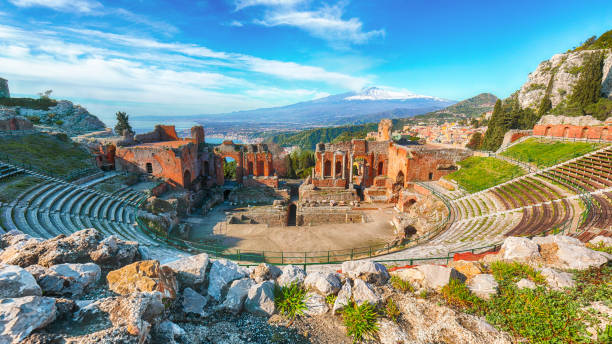What events might have taken place in this ancient theater? In this ancient Greek theater, a myriad of significant events might have unfolded. The theater likely hosted a variety of performances including drama and comedy plays, which were central to Greek culture. These performances would have featured works by famous playwrights such as Aeschylus, Sophocles, Euripides, and Aristophanes. Besides theatrical performances, the theater may also have been a venue for musical contests, poetry readings, and philosophical debates. Public meetings and announcements from civic leaders possibly took place here as well, using the natural acoustics to address large audiences. Theatrical festivals celebrating gods, particularly Dionysus, the god of wine and theater, would have been among the prominent annual events. Imagine the theater during a performance. What might the atmosphere have been like? Picture the theater alive with the energy of an ancient Greek performance. The semi-circular rows would be filled with spectators, eagerly anticipating the show. The hum of the crowd would gradually subside as the play begins, replaced by the rhythmic rise and fall of the actors' voices. The open-air setting allowed natural light to illuminate the stage, creating an interplay of shadows that heightened the dramatic effect. The sound of the Mediterranean breeze, mingling with the distant murmurs of the sea, would add an ambient background to the proceedings. The theater's impressive acoustics carried the actors' voices clearly, even to the farthest seats. As the play progresses, the audience, deeply immersed in the storyline, might respond with audible gasps, laughs, or applause. The scent of wildflowers and the cool touch of the evening air, as the sun set behind Mount Etna, would create an atmosphere of communal enjoyment and cultural reverence. What if a modern concert were held in this ancient theater? Envision a modern concert in this historical gem. The integration of contemporary elements with the ancient architecture would be mesmerizing. Imagine a stage setup carefully preserving the integrity of the historical structure, blending modern LED lights with the ancient stones. The seats, once filled with togas-clad Greeks, now accommodate a diverse audience in modern attire. The acoustics, designed centuries ago to amplify unamplified voices, would now carry the melodies of electric guitars and digital instruments. As the sun sets, the lights illuminate the night, creating a visual spectacle against the backdrop of the sea and Mount Etna. The air thrums with a different kind of energy, yet the setting transcends time, honoring the past as it embraces the present. The experience would be a unique fusion of history and modernity, creating unforgettable memories for all attendees. 